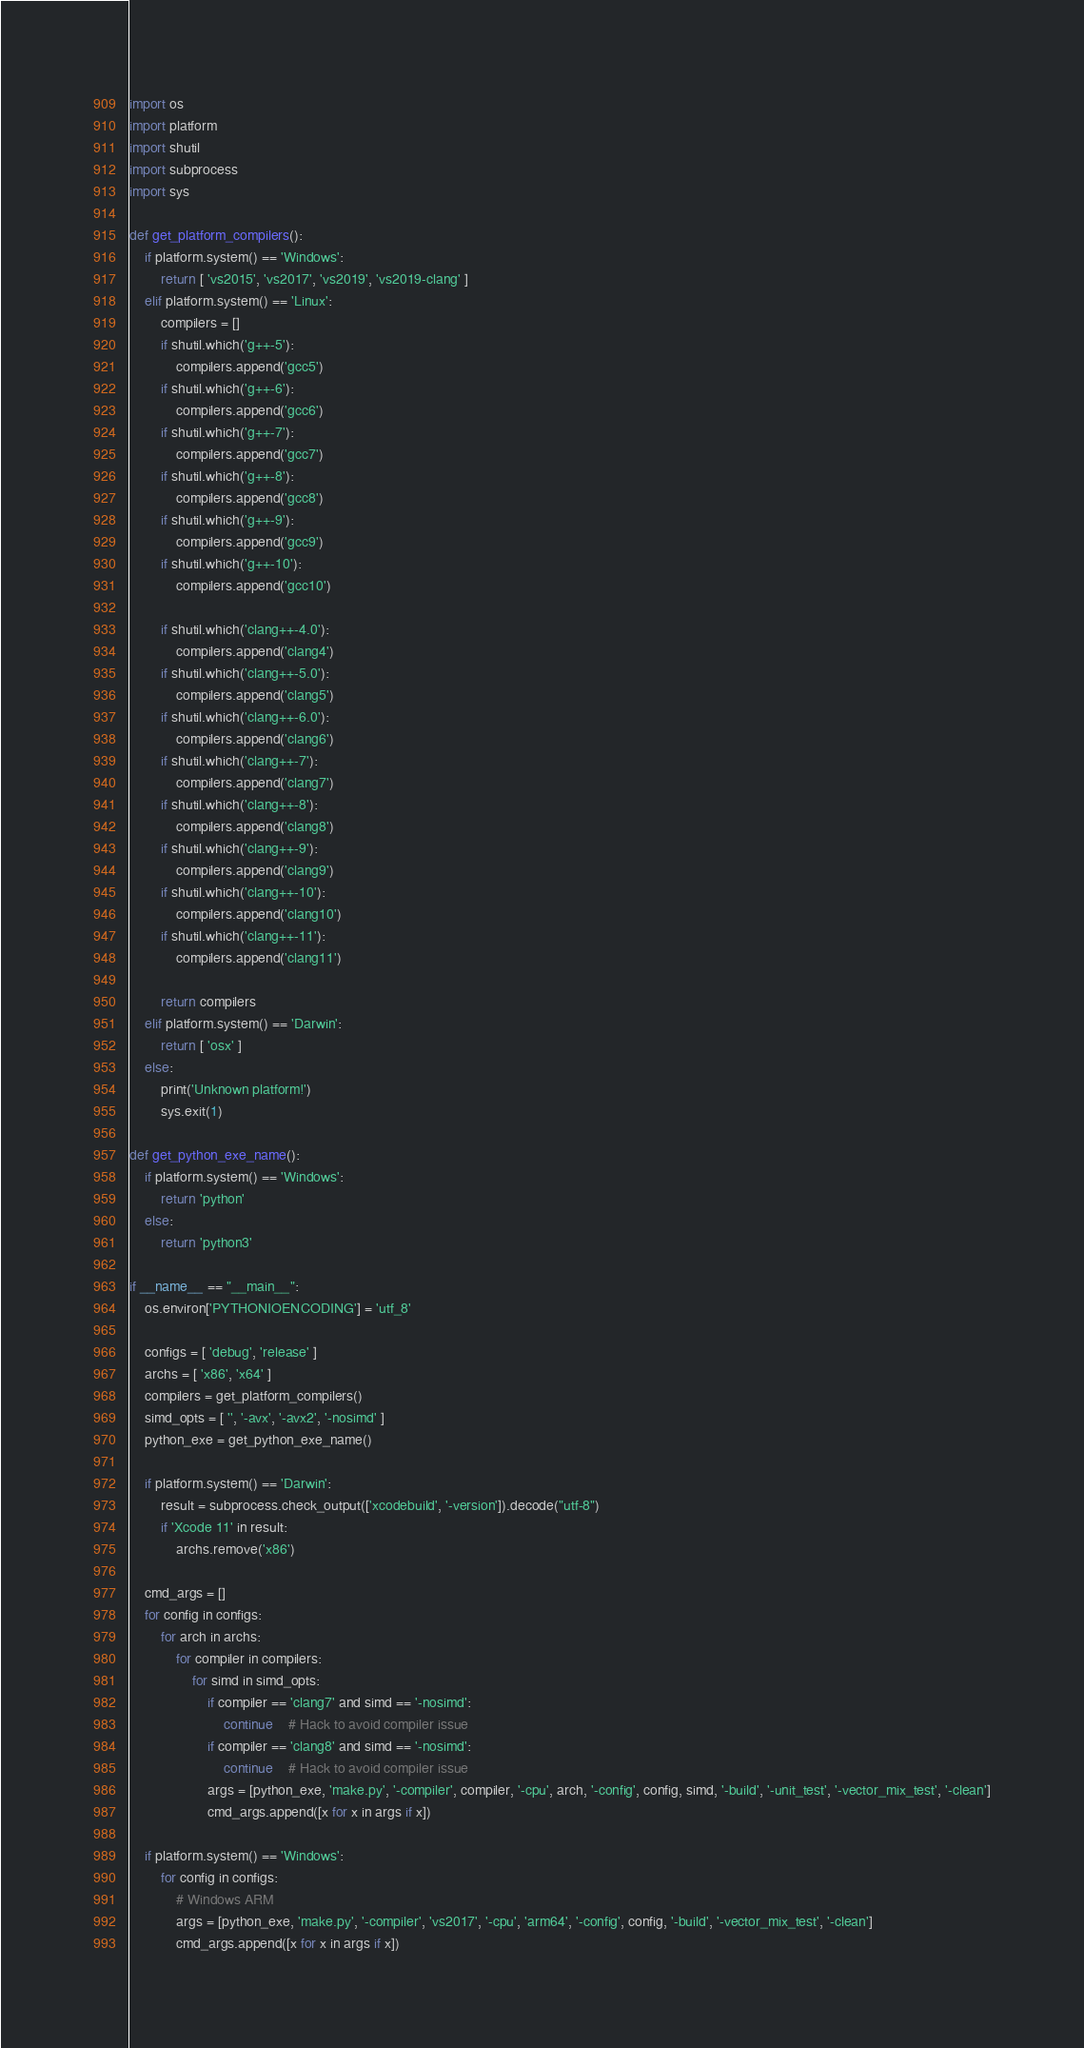<code> <loc_0><loc_0><loc_500><loc_500><_Python_>import os
import platform
import shutil
import subprocess
import sys

def get_platform_compilers():
	if platform.system() == 'Windows':
		return [ 'vs2015', 'vs2017', 'vs2019', 'vs2019-clang' ]
	elif platform.system() == 'Linux':
		compilers = []
		if shutil.which('g++-5'):
			compilers.append('gcc5')
		if shutil.which('g++-6'):
			compilers.append('gcc6')
		if shutil.which('g++-7'):
			compilers.append('gcc7')
		if shutil.which('g++-8'):
			compilers.append('gcc8')
		if shutil.which('g++-9'):
			compilers.append('gcc9')
		if shutil.which('g++-10'):
			compilers.append('gcc10')

		if shutil.which('clang++-4.0'):
			compilers.append('clang4')
		if shutil.which('clang++-5.0'):
			compilers.append('clang5')
		if shutil.which('clang++-6.0'):
			compilers.append('clang6')
		if shutil.which('clang++-7'):
			compilers.append('clang7')
		if shutil.which('clang++-8'):
			compilers.append('clang8')
		if shutil.which('clang++-9'):
			compilers.append('clang9')
		if shutil.which('clang++-10'):
			compilers.append('clang10')
		if shutil.which('clang++-11'):
			compilers.append('clang11')

		return compilers
	elif platform.system() == 'Darwin':
		return [ 'osx' ]
	else:
		print('Unknown platform!')
		sys.exit(1)

def get_python_exe_name():
	if platform.system() == 'Windows':
		return 'python'
	else:
		return 'python3'

if __name__ == "__main__":
	os.environ['PYTHONIOENCODING'] = 'utf_8'

	configs = [ 'debug', 'release' ]
	archs = [ 'x86', 'x64' ]
	compilers = get_platform_compilers()
	simd_opts = [ '', '-avx', '-avx2', '-nosimd' ]
	python_exe = get_python_exe_name()

	if platform.system() == 'Darwin':
		result = subprocess.check_output(['xcodebuild', '-version']).decode("utf-8")
		if 'Xcode 11' in result:
			archs.remove('x86')

	cmd_args = []
	for config in configs:
		for arch in archs:
			for compiler in compilers:
				for simd in simd_opts:
					if compiler == 'clang7' and simd == '-nosimd':
						continue	# Hack to avoid compiler issue
					if compiler == 'clang8' and simd == '-nosimd':
						continue	# Hack to avoid compiler issue
					args = [python_exe, 'make.py', '-compiler', compiler, '-cpu', arch, '-config', config, simd, '-build', '-unit_test', '-vector_mix_test', '-clean']
					cmd_args.append([x for x in args if x])

	if platform.system() == 'Windows':
		for config in configs:
			# Windows ARM
			args = [python_exe, 'make.py', '-compiler', 'vs2017', '-cpu', 'arm64', '-config', config, '-build', '-vector_mix_test', '-clean']
			cmd_args.append([x for x in args if x])</code> 